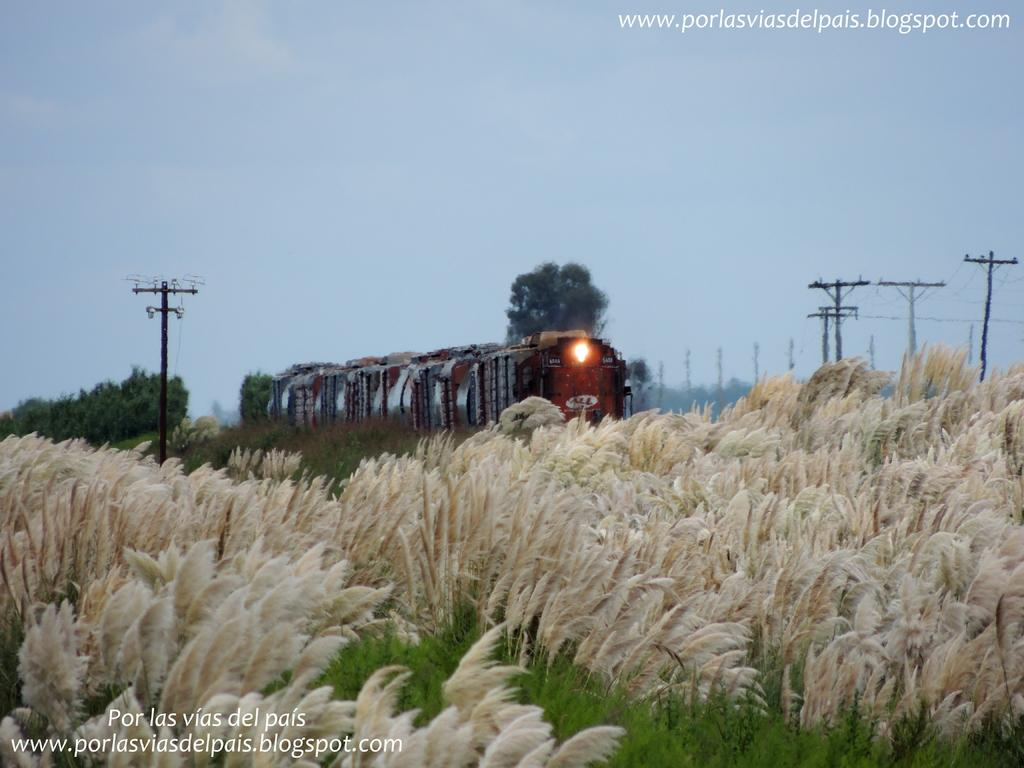What is the main subject of the image? There is a train in the image. What can be seen in the background of the image? The sky is visible in the background of the image. What type of vegetation is present in the image? There are trees and plants in the image. What else can be seen in the image besides the train and vegetation? There are poles with wires in the image. Is there any text present in the image? Yes, there is text at the bottom and top of the image. What type of flame can be seen coming from the train in the image? There is no flame present in the image; it is a train without any visible fire or heat source. 